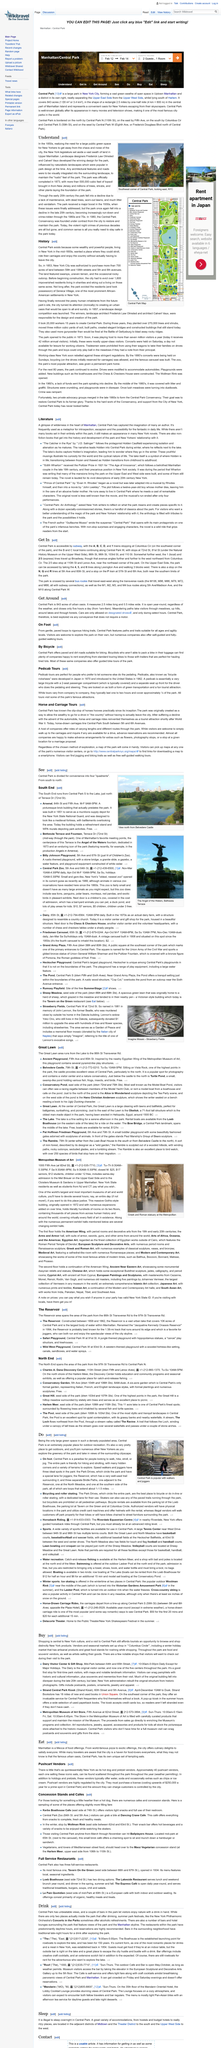Indicate a few pertinent items in this graphic. The website is advertising the area of Manhattan. Central Park is a popular destination for walkers and joggers due to its picturesque scenery, well-maintained paths, and ample space for exercise and recreation. The photo was taken in the northern direction from Belvedere Castle. Central Park can be accessed by various modes of transportation, including subway and trains, according to the topic "Get In. You can find a stop on the N, Q and R lines at 5th Ave and 60th St. 